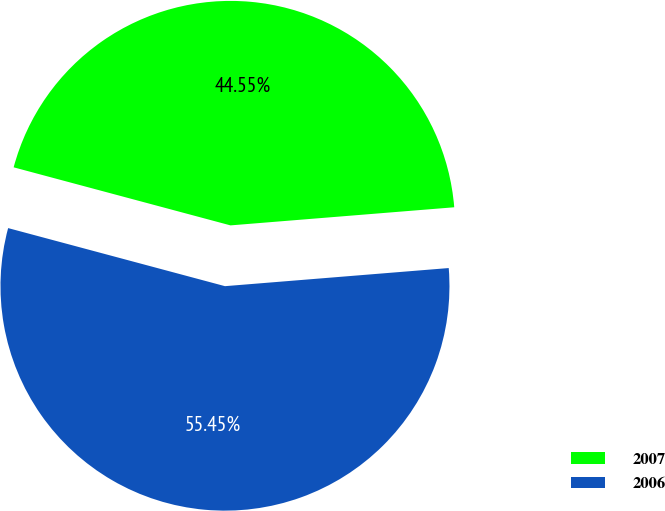Convert chart to OTSL. <chart><loc_0><loc_0><loc_500><loc_500><pie_chart><fcel>2007<fcel>2006<nl><fcel>44.55%<fcel>55.45%<nl></chart> 